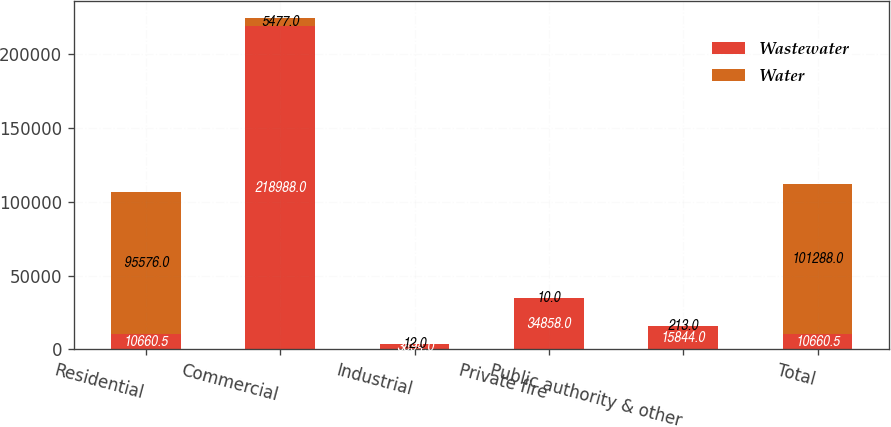<chart> <loc_0><loc_0><loc_500><loc_500><stacked_bar_chart><ecel><fcel>Residential<fcel>Commercial<fcel>Industrial<fcel>Private fire<fcel>Public authority & other<fcel>Total<nl><fcel>Wastewater<fcel>10660.5<fcel>218988<fcel>3894<fcel>34858<fcel>15844<fcel>10660.5<nl><fcel>Water<fcel>95576<fcel>5477<fcel>12<fcel>10<fcel>213<fcel>101288<nl></chart> 